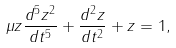<formula> <loc_0><loc_0><loc_500><loc_500>\mu z \frac { d ^ { 5 } z ^ { 2 } } { d t ^ { 5 } } + \frac { d ^ { 2 } z } { d t ^ { 2 } } + z = 1 ,</formula> 